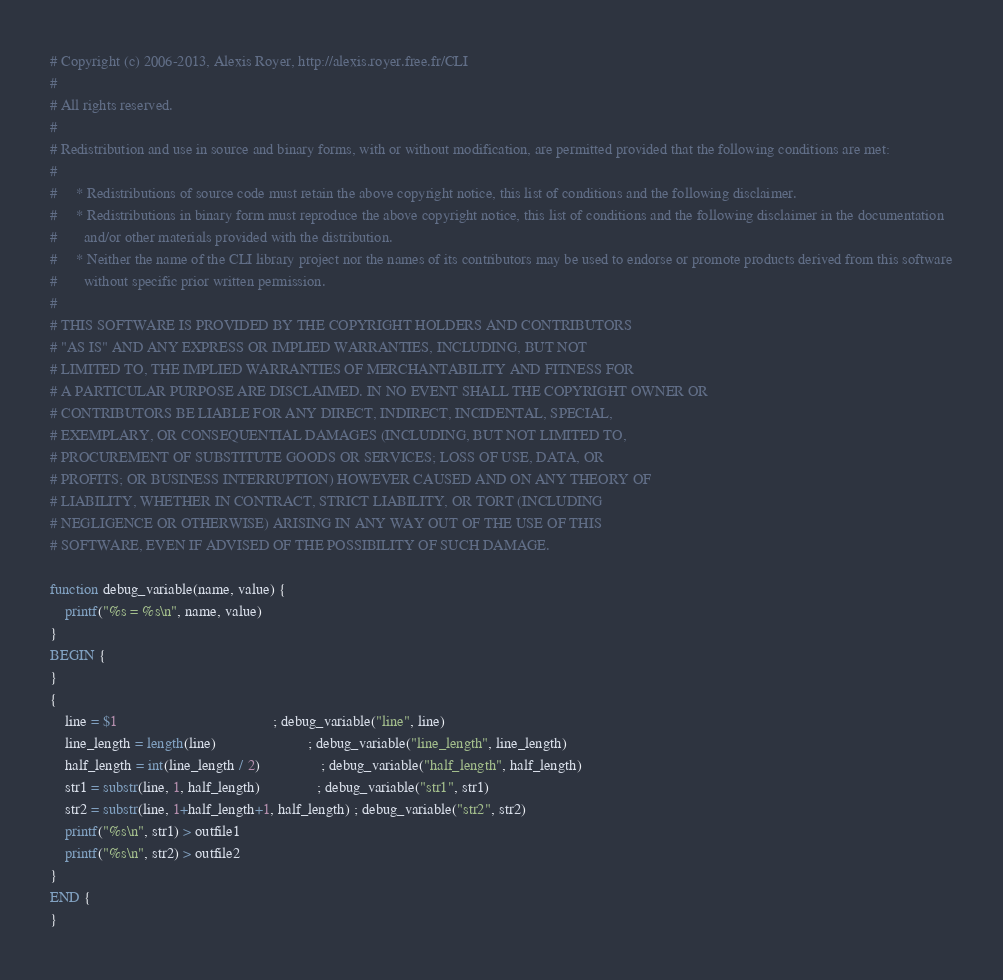Convert code to text. <code><loc_0><loc_0><loc_500><loc_500><_Awk_># Copyright (c) 2006-2013, Alexis Royer, http://alexis.royer.free.fr/CLI
#
# All rights reserved.
#
# Redistribution and use in source and binary forms, with or without modification, are permitted provided that the following conditions are met:
#
#     * Redistributions of source code must retain the above copyright notice, this list of conditions and the following disclaimer.
#     * Redistributions in binary form must reproduce the above copyright notice, this list of conditions and the following disclaimer in the documentation
#       and/or other materials provided with the distribution.
#     * Neither the name of the CLI library project nor the names of its contributors may be used to endorse or promote products derived from this software
#       without specific prior written permission.
#
# THIS SOFTWARE IS PROVIDED BY THE COPYRIGHT HOLDERS AND CONTRIBUTORS
# "AS IS" AND ANY EXPRESS OR IMPLIED WARRANTIES, INCLUDING, BUT NOT
# LIMITED TO, THE IMPLIED WARRANTIES OF MERCHANTABILITY AND FITNESS FOR
# A PARTICULAR PURPOSE ARE DISCLAIMED. IN NO EVENT SHALL THE COPYRIGHT OWNER OR
# CONTRIBUTORS BE LIABLE FOR ANY DIRECT, INDIRECT, INCIDENTAL, SPECIAL,
# EXEMPLARY, OR CONSEQUENTIAL DAMAGES (INCLUDING, BUT NOT LIMITED TO,
# PROCUREMENT OF SUBSTITUTE GOODS OR SERVICES; LOSS OF USE, DATA, OR
# PROFITS; OR BUSINESS INTERRUPTION) HOWEVER CAUSED AND ON ANY THEORY OF
# LIABILITY, WHETHER IN CONTRACT, STRICT LIABILITY, OR TORT (INCLUDING
# NEGLIGENCE OR OTHERWISE) ARISING IN ANY WAY OUT OF THE USE OF THIS
# SOFTWARE, EVEN IF ADVISED OF THE POSSIBILITY OF SUCH DAMAGE.

function debug_variable(name, value) {
    printf("%s = %s\n", name, value)
}
BEGIN {
}
{
    line = $1                                         ; debug_variable("line", line)
    line_length = length(line)                        ; debug_variable("line_length", line_length)
    half_length = int(line_length / 2)                ; debug_variable("half_length", half_length)
    str1 = substr(line, 1, half_length)               ; debug_variable("str1", str1)
    str2 = substr(line, 1+half_length+1, half_length) ; debug_variable("str2", str2)
    printf("%s\n", str1) > outfile1
    printf("%s\n", str2) > outfile2
}
END {
}
</code> 